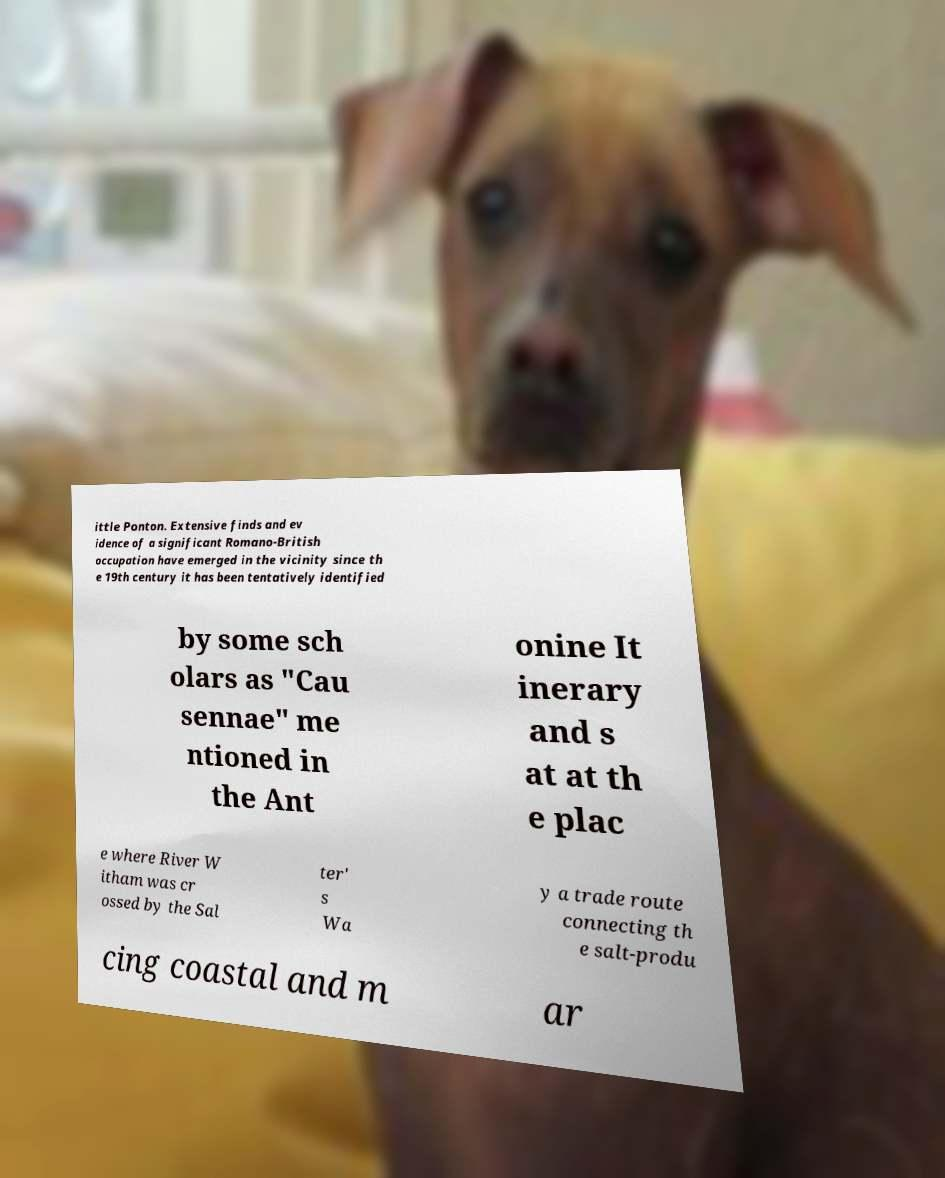I need the written content from this picture converted into text. Can you do that? ittle Ponton. Extensive finds and ev idence of a significant Romano-British occupation have emerged in the vicinity since th e 19th century it has been tentatively identified by some sch olars as "Cau sennae" me ntioned in the Ant onine It inerary and s at at th e plac e where River W itham was cr ossed by the Sal ter' s Wa y a trade route connecting th e salt-produ cing coastal and m ar 